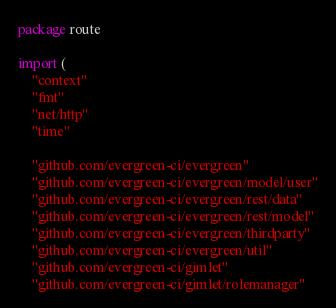Convert code to text. <code><loc_0><loc_0><loc_500><loc_500><_Go_>package route

import (
	"context"
	"fmt"
	"net/http"
	"time"

	"github.com/evergreen-ci/evergreen"
	"github.com/evergreen-ci/evergreen/model/user"
	"github.com/evergreen-ci/evergreen/rest/data"
	"github.com/evergreen-ci/evergreen/rest/model"
	"github.com/evergreen-ci/evergreen/thirdparty"
	"github.com/evergreen-ci/evergreen/util"
	"github.com/evergreen-ci/gimlet"
	"github.com/evergreen-ci/gimlet/rolemanager"</code> 